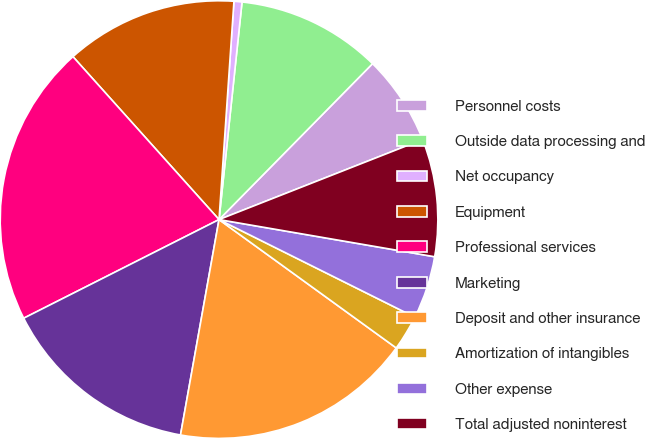<chart> <loc_0><loc_0><loc_500><loc_500><pie_chart><fcel>Personnel costs<fcel>Outside data processing and<fcel>Net occupancy<fcel>Equipment<fcel>Professional services<fcel>Marketing<fcel>Deposit and other insurance<fcel>Amortization of intangibles<fcel>Other expense<fcel>Total adjusted noninterest<nl><fcel>6.66%<fcel>10.7%<fcel>0.59%<fcel>12.72%<fcel>20.81%<fcel>14.74%<fcel>17.84%<fcel>2.62%<fcel>4.64%<fcel>8.68%<nl></chart> 